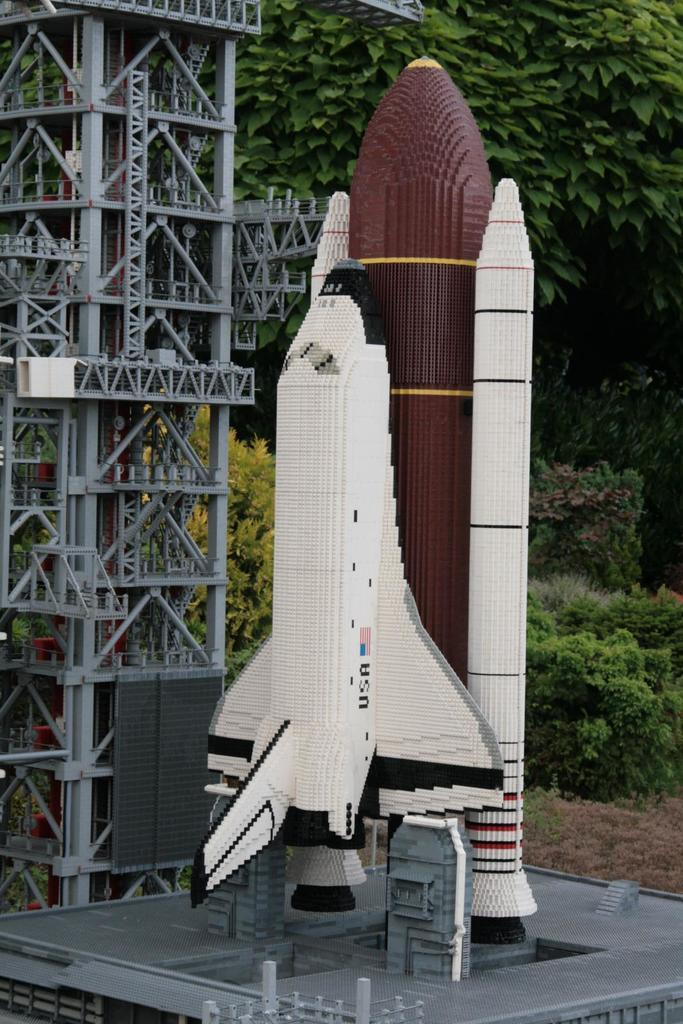What is the main subject of the image? The main subject of the image is a space shuttle. Can you describe the space shuttle in the image? The space shuttle appears to be artificial. What can be seen in the background of the image? There are plants and trees in the background of the image. What type of boats can be seen sailing in the image? There are no boats present in the image; it features a space shuttle and background elements. 